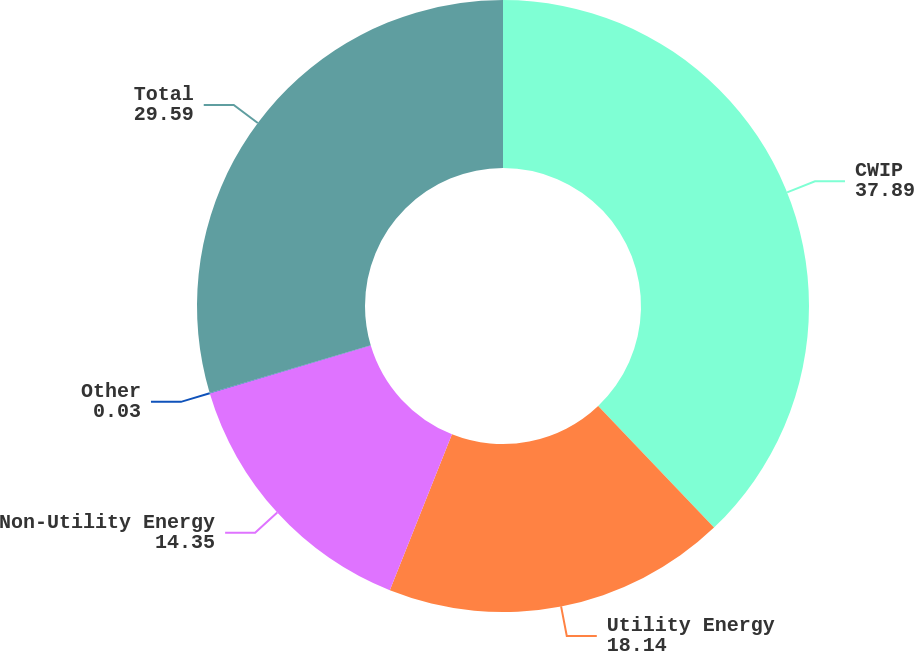Convert chart. <chart><loc_0><loc_0><loc_500><loc_500><pie_chart><fcel>CWIP<fcel>Utility Energy<fcel>Non-Utility Energy<fcel>Other<fcel>Total<nl><fcel>37.89%<fcel>18.14%<fcel>14.35%<fcel>0.03%<fcel>29.59%<nl></chart> 